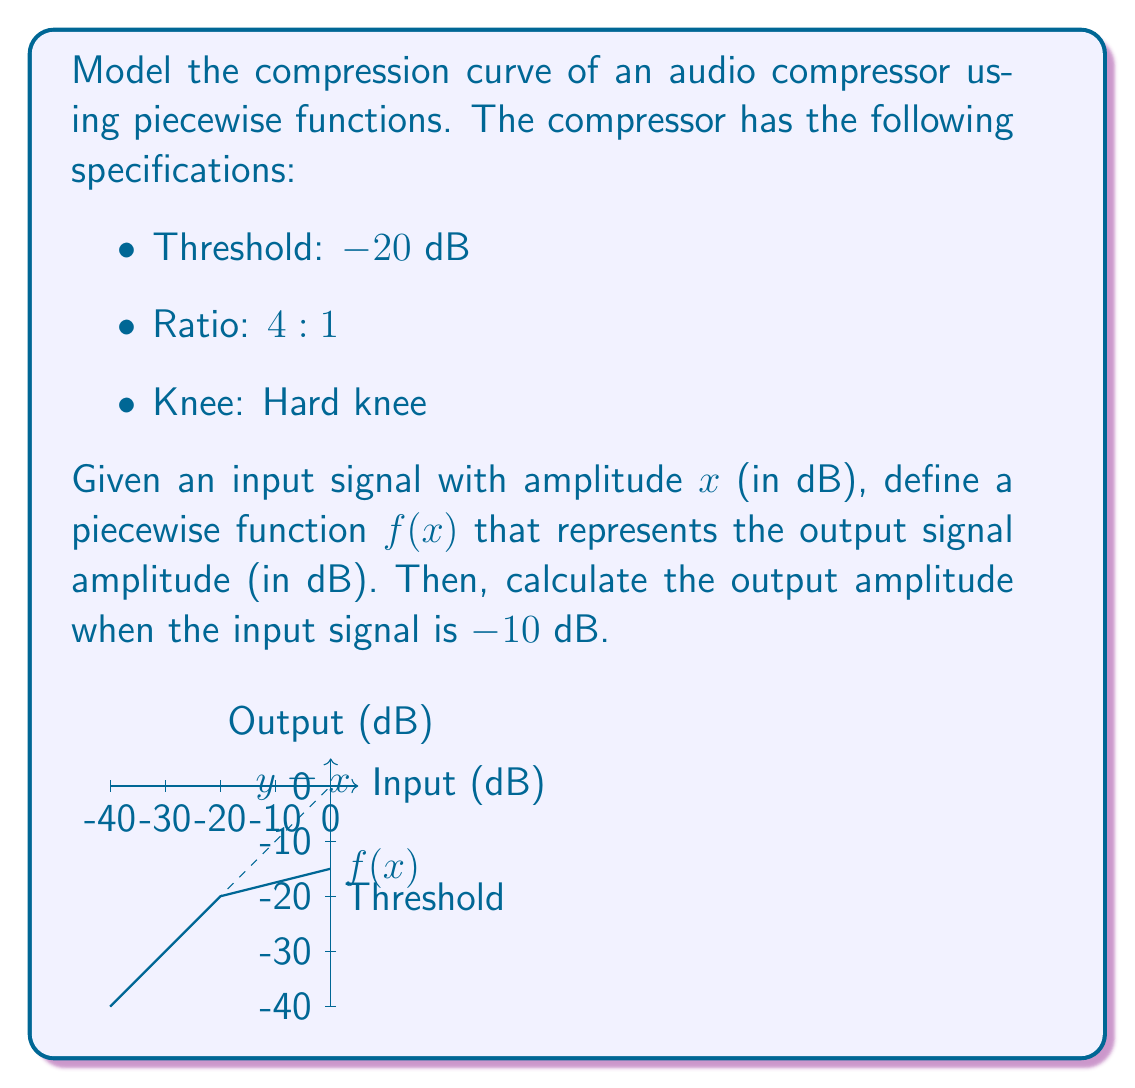Can you answer this question? To model the compression curve, we need to define a piecewise function based on the given specifications:

1. For input levels below the threshold (-20 dB), the output is equal to the input (1:1 ratio).
2. For input levels above the threshold, the output is compressed with a 4:1 ratio.

Let's define the piecewise function f(x):

$$f(x) = \begin{cases}
x & \text{if } x \leq -20 \\
-20 + \frac{x+20}{4} & \text{if } x > -20
\end{cases}$$

To calculate the output amplitude when the input signal is -10 dB:

1. Since -10 dB is above the threshold (-20 dB), we use the second piece of the function.
2. Substitute x = -10 into the equation:

   $$f(-10) = -20 + \frac{-10+20}{4}$$

3. Simplify:
   $$f(-10) = -20 + \frac{10}{4} = -20 + 2.5 = -17.5$$

Therefore, when the input signal is -10 dB, the output signal will be -17.5 dB.
Answer: $f(x) = \begin{cases}
x & \text{if } x \leq -20 \\
-20 + \frac{x+20}{4} & \text{if } x > -20
\end{cases}$; Output at -10 dB input: -17.5 dB 